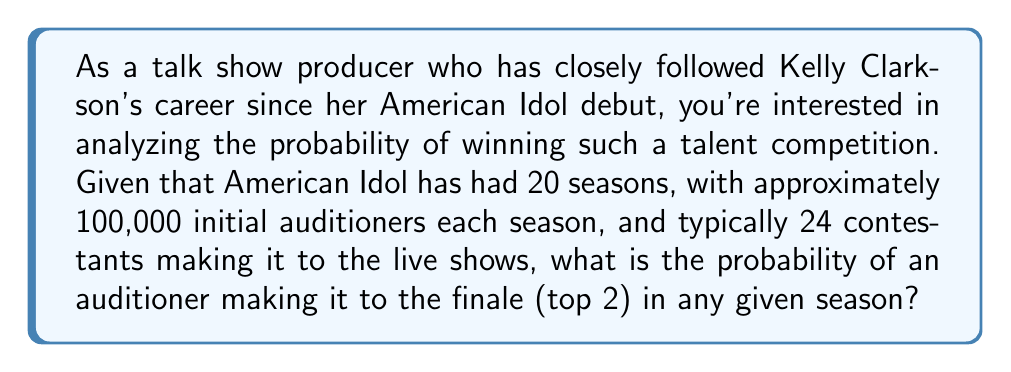Give your solution to this math problem. To solve this problem, we need to follow these steps:

1. Identify the total number of auditioners:
   $$ \text{Total auditioners per season} = 100,000 $$

2. Determine the number of contestants who make it to the live shows:
   $$ \text{Live show contestants} = 24 $$

3. Calculate the number of finalists (top 2):
   $$ \text{Finalists} = 2 $$

4. Calculate the probability of making it to the live shows:
   $$ P(\text{Live shows}) = \frac{\text{Live show contestants}}{\text{Total auditioners}} = \frac{24}{100,000} = 0.00024 $$

5. Calculate the probability of making it to the finale, given that a contestant has made it to the live shows:
   $$ P(\text{Finale} | \text{Live shows}) = \frac{\text{Finalists}}{\text{Live show contestants}} = \frac{2}{24} = \frac{1}{12} \approx 0.0833 $$

6. Calculate the overall probability of making it to the finale:
   $$ P(\text{Finale}) = P(\text{Live shows}) \times P(\text{Finale} | \text{Live shows}) $$
   $$ P(\text{Finale}) = 0.00024 \times \frac{1}{12} = 0.00002 $$

This probability can also be expressed as a fraction:
$$ P(\text{Finale}) = \frac{2}{100,000} = \frac{1}{50,000} $$
Answer: The probability of an auditioner making it to the finale (top 2) in any given season of American Idol is $\frac{1}{50,000}$ or 0.00002 (0.002%). 